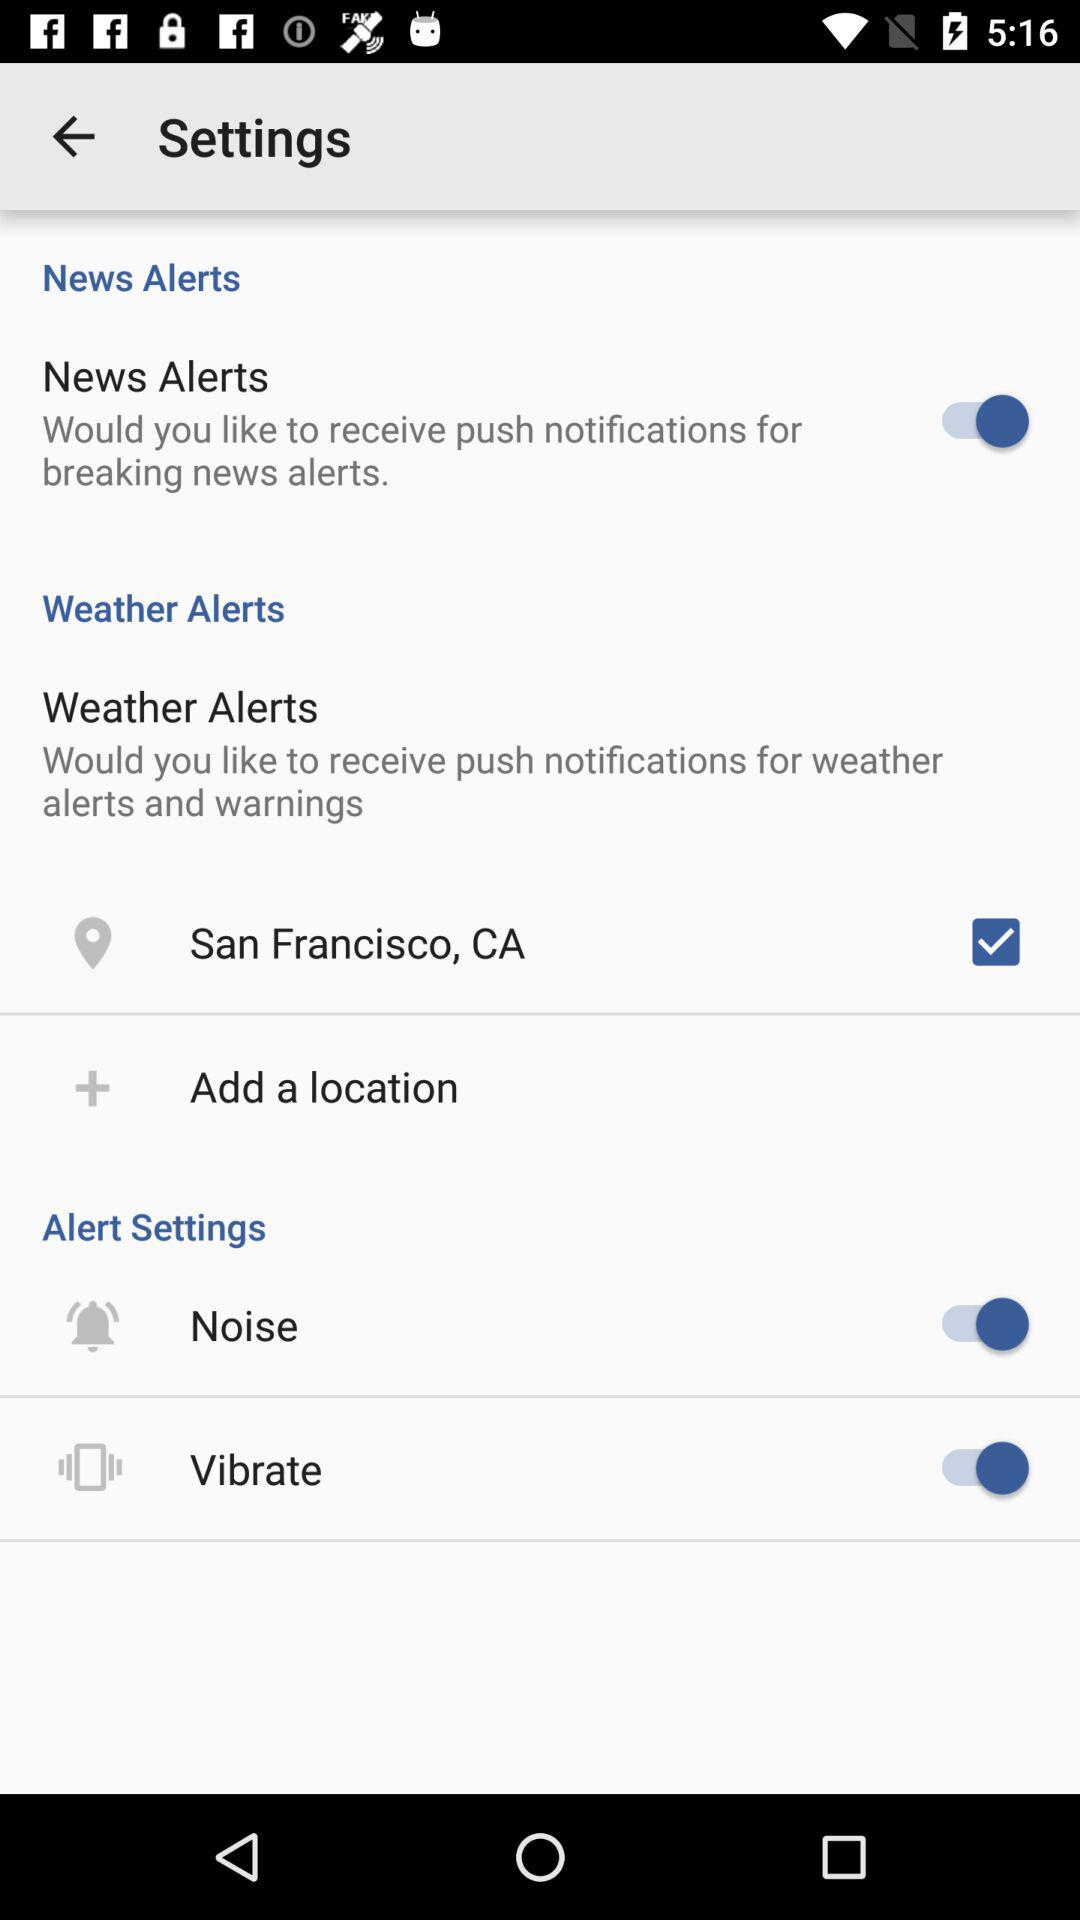What is the status of noise? The status is on. 